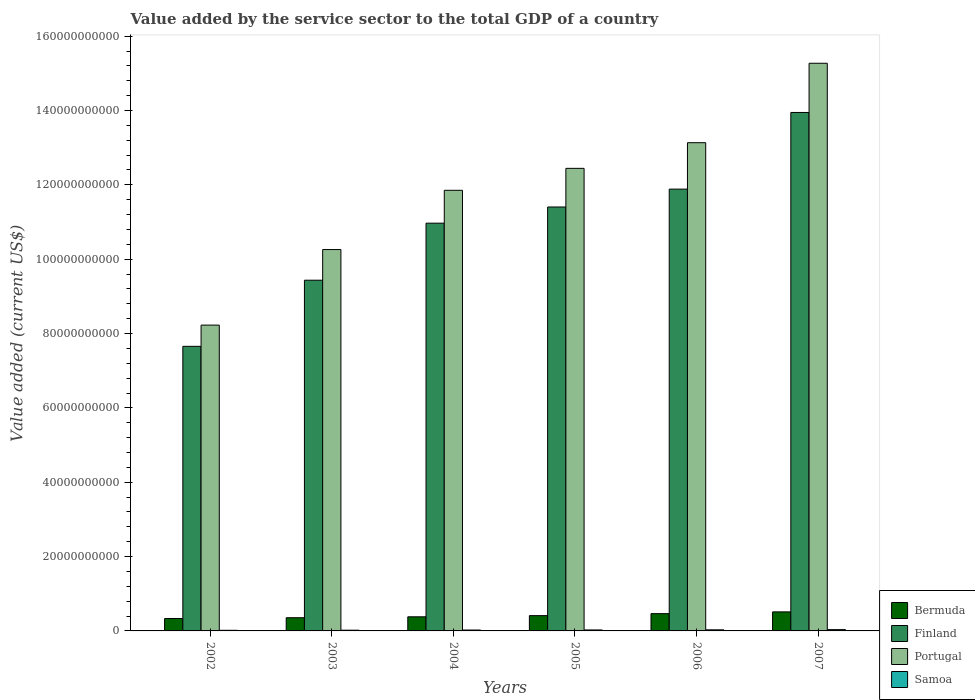How many bars are there on the 5th tick from the right?
Keep it short and to the point. 4. What is the value added by the service sector to the total GDP in Samoa in 2005?
Offer a very short reply. 2.63e+08. Across all years, what is the maximum value added by the service sector to the total GDP in Finland?
Your answer should be very brief. 1.39e+11. Across all years, what is the minimum value added by the service sector to the total GDP in Finland?
Your answer should be very brief. 7.66e+1. In which year was the value added by the service sector to the total GDP in Samoa minimum?
Your response must be concise. 2002. What is the total value added by the service sector to the total GDP in Samoa in the graph?
Keep it short and to the point. 1.51e+09. What is the difference between the value added by the service sector to the total GDP in Samoa in 2006 and that in 2007?
Provide a succinct answer. -5.72e+07. What is the difference between the value added by the service sector to the total GDP in Samoa in 2007 and the value added by the service sector to the total GDP in Finland in 2003?
Ensure brevity in your answer.  -9.40e+1. What is the average value added by the service sector to the total GDP in Bermuda per year?
Your answer should be compact. 4.10e+09. In the year 2004, what is the difference between the value added by the service sector to the total GDP in Samoa and value added by the service sector to the total GDP in Finland?
Offer a very short reply. -1.09e+11. What is the ratio of the value added by the service sector to the total GDP in Bermuda in 2004 to that in 2006?
Make the answer very short. 0.82. Is the difference between the value added by the service sector to the total GDP in Samoa in 2002 and 2006 greater than the difference between the value added by the service sector to the total GDP in Finland in 2002 and 2006?
Ensure brevity in your answer.  Yes. What is the difference between the highest and the second highest value added by the service sector to the total GDP in Bermuda?
Provide a succinct answer. 4.77e+08. What is the difference between the highest and the lowest value added by the service sector to the total GDP in Bermuda?
Your answer should be compact. 1.78e+09. What does the 1st bar from the right in 2003 represents?
Your answer should be compact. Samoa. How many bars are there?
Your response must be concise. 24. How are the legend labels stacked?
Your response must be concise. Vertical. What is the title of the graph?
Provide a short and direct response. Value added by the service sector to the total GDP of a country. Does "Denmark" appear as one of the legend labels in the graph?
Ensure brevity in your answer.  No. What is the label or title of the Y-axis?
Your response must be concise. Value added (current US$). What is the Value added (current US$) of Bermuda in 2002?
Ensure brevity in your answer.  3.34e+09. What is the Value added (current US$) of Finland in 2002?
Make the answer very short. 7.66e+1. What is the Value added (current US$) of Portugal in 2002?
Provide a short and direct response. 8.23e+1. What is the Value added (current US$) of Samoa in 2002?
Your answer should be compact. 1.65e+08. What is the Value added (current US$) of Bermuda in 2003?
Provide a succinct answer. 3.55e+09. What is the Value added (current US$) of Finland in 2003?
Ensure brevity in your answer.  9.43e+1. What is the Value added (current US$) in Portugal in 2003?
Ensure brevity in your answer.  1.03e+11. What is the Value added (current US$) of Samoa in 2003?
Your answer should be very brief. 1.94e+08. What is the Value added (current US$) in Bermuda in 2004?
Offer a very short reply. 3.80e+09. What is the Value added (current US$) of Finland in 2004?
Offer a terse response. 1.10e+11. What is the Value added (current US$) of Portugal in 2004?
Your answer should be very brief. 1.19e+11. What is the Value added (current US$) of Samoa in 2004?
Offer a very short reply. 2.37e+08. What is the Value added (current US$) of Bermuda in 2005?
Your response must be concise. 4.11e+09. What is the Value added (current US$) of Finland in 2005?
Your answer should be compact. 1.14e+11. What is the Value added (current US$) in Portugal in 2005?
Your answer should be compact. 1.24e+11. What is the Value added (current US$) of Samoa in 2005?
Give a very brief answer. 2.63e+08. What is the Value added (current US$) in Bermuda in 2006?
Offer a terse response. 4.65e+09. What is the Value added (current US$) of Finland in 2006?
Offer a very short reply. 1.19e+11. What is the Value added (current US$) of Portugal in 2006?
Give a very brief answer. 1.31e+11. What is the Value added (current US$) in Samoa in 2006?
Your response must be concise. 2.94e+08. What is the Value added (current US$) of Bermuda in 2007?
Your answer should be compact. 5.12e+09. What is the Value added (current US$) of Finland in 2007?
Give a very brief answer. 1.39e+11. What is the Value added (current US$) in Portugal in 2007?
Make the answer very short. 1.53e+11. What is the Value added (current US$) of Samoa in 2007?
Your answer should be very brief. 3.51e+08. Across all years, what is the maximum Value added (current US$) in Bermuda?
Your answer should be very brief. 5.12e+09. Across all years, what is the maximum Value added (current US$) of Finland?
Offer a very short reply. 1.39e+11. Across all years, what is the maximum Value added (current US$) in Portugal?
Give a very brief answer. 1.53e+11. Across all years, what is the maximum Value added (current US$) of Samoa?
Give a very brief answer. 3.51e+08. Across all years, what is the minimum Value added (current US$) of Bermuda?
Give a very brief answer. 3.34e+09. Across all years, what is the minimum Value added (current US$) in Finland?
Provide a short and direct response. 7.66e+1. Across all years, what is the minimum Value added (current US$) in Portugal?
Your answer should be very brief. 8.23e+1. Across all years, what is the minimum Value added (current US$) in Samoa?
Provide a short and direct response. 1.65e+08. What is the total Value added (current US$) in Bermuda in the graph?
Offer a terse response. 2.46e+1. What is the total Value added (current US$) in Finland in the graph?
Keep it short and to the point. 6.53e+11. What is the total Value added (current US$) in Portugal in the graph?
Your answer should be very brief. 7.12e+11. What is the total Value added (current US$) in Samoa in the graph?
Make the answer very short. 1.51e+09. What is the difference between the Value added (current US$) in Bermuda in 2002 and that in 2003?
Give a very brief answer. -2.14e+08. What is the difference between the Value added (current US$) of Finland in 2002 and that in 2003?
Offer a very short reply. -1.78e+1. What is the difference between the Value added (current US$) in Portugal in 2002 and that in 2003?
Provide a short and direct response. -2.03e+1. What is the difference between the Value added (current US$) in Samoa in 2002 and that in 2003?
Provide a succinct answer. -2.92e+07. What is the difference between the Value added (current US$) in Bermuda in 2002 and that in 2004?
Give a very brief answer. -4.59e+08. What is the difference between the Value added (current US$) of Finland in 2002 and that in 2004?
Ensure brevity in your answer.  -3.31e+1. What is the difference between the Value added (current US$) in Portugal in 2002 and that in 2004?
Make the answer very short. -3.63e+1. What is the difference between the Value added (current US$) of Samoa in 2002 and that in 2004?
Offer a very short reply. -7.17e+07. What is the difference between the Value added (current US$) of Bermuda in 2002 and that in 2005?
Keep it short and to the point. -7.73e+08. What is the difference between the Value added (current US$) of Finland in 2002 and that in 2005?
Provide a succinct answer. -3.75e+1. What is the difference between the Value added (current US$) of Portugal in 2002 and that in 2005?
Ensure brevity in your answer.  -4.22e+1. What is the difference between the Value added (current US$) in Samoa in 2002 and that in 2005?
Your answer should be compact. -9.82e+07. What is the difference between the Value added (current US$) in Bermuda in 2002 and that in 2006?
Your answer should be compact. -1.31e+09. What is the difference between the Value added (current US$) in Finland in 2002 and that in 2006?
Give a very brief answer. -4.23e+1. What is the difference between the Value added (current US$) of Portugal in 2002 and that in 2006?
Ensure brevity in your answer.  -4.91e+1. What is the difference between the Value added (current US$) in Samoa in 2002 and that in 2006?
Ensure brevity in your answer.  -1.29e+08. What is the difference between the Value added (current US$) in Bermuda in 2002 and that in 2007?
Your answer should be compact. -1.78e+09. What is the difference between the Value added (current US$) of Finland in 2002 and that in 2007?
Your answer should be very brief. -6.29e+1. What is the difference between the Value added (current US$) in Portugal in 2002 and that in 2007?
Ensure brevity in your answer.  -7.04e+1. What is the difference between the Value added (current US$) of Samoa in 2002 and that in 2007?
Your answer should be very brief. -1.86e+08. What is the difference between the Value added (current US$) of Bermuda in 2003 and that in 2004?
Give a very brief answer. -2.45e+08. What is the difference between the Value added (current US$) in Finland in 2003 and that in 2004?
Ensure brevity in your answer.  -1.53e+1. What is the difference between the Value added (current US$) of Portugal in 2003 and that in 2004?
Offer a very short reply. -1.59e+1. What is the difference between the Value added (current US$) of Samoa in 2003 and that in 2004?
Provide a succinct answer. -4.25e+07. What is the difference between the Value added (current US$) in Bermuda in 2003 and that in 2005?
Offer a terse response. -5.59e+08. What is the difference between the Value added (current US$) of Finland in 2003 and that in 2005?
Offer a very short reply. -1.97e+1. What is the difference between the Value added (current US$) of Portugal in 2003 and that in 2005?
Provide a succinct answer. -2.18e+1. What is the difference between the Value added (current US$) of Samoa in 2003 and that in 2005?
Keep it short and to the point. -6.90e+07. What is the difference between the Value added (current US$) in Bermuda in 2003 and that in 2006?
Offer a very short reply. -1.09e+09. What is the difference between the Value added (current US$) of Finland in 2003 and that in 2006?
Keep it short and to the point. -2.45e+1. What is the difference between the Value added (current US$) in Portugal in 2003 and that in 2006?
Ensure brevity in your answer.  -2.87e+1. What is the difference between the Value added (current US$) in Samoa in 2003 and that in 2006?
Keep it short and to the point. -9.98e+07. What is the difference between the Value added (current US$) of Bermuda in 2003 and that in 2007?
Keep it short and to the point. -1.57e+09. What is the difference between the Value added (current US$) of Finland in 2003 and that in 2007?
Make the answer very short. -4.51e+1. What is the difference between the Value added (current US$) of Portugal in 2003 and that in 2007?
Provide a short and direct response. -5.01e+1. What is the difference between the Value added (current US$) of Samoa in 2003 and that in 2007?
Ensure brevity in your answer.  -1.57e+08. What is the difference between the Value added (current US$) of Bermuda in 2004 and that in 2005?
Your answer should be very brief. -3.14e+08. What is the difference between the Value added (current US$) in Finland in 2004 and that in 2005?
Your response must be concise. -4.35e+09. What is the difference between the Value added (current US$) in Portugal in 2004 and that in 2005?
Offer a terse response. -5.91e+09. What is the difference between the Value added (current US$) of Samoa in 2004 and that in 2005?
Provide a short and direct response. -2.65e+07. What is the difference between the Value added (current US$) in Bermuda in 2004 and that in 2006?
Your response must be concise. -8.46e+08. What is the difference between the Value added (current US$) of Finland in 2004 and that in 2006?
Offer a terse response. -9.16e+09. What is the difference between the Value added (current US$) in Portugal in 2004 and that in 2006?
Provide a short and direct response. -1.28e+1. What is the difference between the Value added (current US$) of Samoa in 2004 and that in 2006?
Provide a short and direct response. -5.73e+07. What is the difference between the Value added (current US$) of Bermuda in 2004 and that in 2007?
Provide a short and direct response. -1.32e+09. What is the difference between the Value added (current US$) in Finland in 2004 and that in 2007?
Provide a short and direct response. -2.98e+1. What is the difference between the Value added (current US$) in Portugal in 2004 and that in 2007?
Offer a very short reply. -3.42e+1. What is the difference between the Value added (current US$) in Samoa in 2004 and that in 2007?
Offer a terse response. -1.15e+08. What is the difference between the Value added (current US$) in Bermuda in 2005 and that in 2006?
Your answer should be compact. -5.32e+08. What is the difference between the Value added (current US$) of Finland in 2005 and that in 2006?
Make the answer very short. -4.81e+09. What is the difference between the Value added (current US$) in Portugal in 2005 and that in 2006?
Offer a very short reply. -6.90e+09. What is the difference between the Value added (current US$) of Samoa in 2005 and that in 2006?
Ensure brevity in your answer.  -3.08e+07. What is the difference between the Value added (current US$) of Bermuda in 2005 and that in 2007?
Your answer should be compact. -1.01e+09. What is the difference between the Value added (current US$) of Finland in 2005 and that in 2007?
Make the answer very short. -2.54e+1. What is the difference between the Value added (current US$) of Portugal in 2005 and that in 2007?
Make the answer very short. -2.83e+1. What is the difference between the Value added (current US$) in Samoa in 2005 and that in 2007?
Provide a short and direct response. -8.81e+07. What is the difference between the Value added (current US$) in Bermuda in 2006 and that in 2007?
Give a very brief answer. -4.77e+08. What is the difference between the Value added (current US$) of Finland in 2006 and that in 2007?
Ensure brevity in your answer.  -2.06e+1. What is the difference between the Value added (current US$) in Portugal in 2006 and that in 2007?
Make the answer very short. -2.14e+1. What is the difference between the Value added (current US$) of Samoa in 2006 and that in 2007?
Give a very brief answer. -5.72e+07. What is the difference between the Value added (current US$) in Bermuda in 2002 and the Value added (current US$) in Finland in 2003?
Make the answer very short. -9.10e+1. What is the difference between the Value added (current US$) of Bermuda in 2002 and the Value added (current US$) of Portugal in 2003?
Offer a very short reply. -9.93e+1. What is the difference between the Value added (current US$) in Bermuda in 2002 and the Value added (current US$) in Samoa in 2003?
Your answer should be very brief. 3.15e+09. What is the difference between the Value added (current US$) of Finland in 2002 and the Value added (current US$) of Portugal in 2003?
Ensure brevity in your answer.  -2.60e+1. What is the difference between the Value added (current US$) of Finland in 2002 and the Value added (current US$) of Samoa in 2003?
Your response must be concise. 7.64e+1. What is the difference between the Value added (current US$) of Portugal in 2002 and the Value added (current US$) of Samoa in 2003?
Offer a terse response. 8.21e+1. What is the difference between the Value added (current US$) in Bermuda in 2002 and the Value added (current US$) in Finland in 2004?
Your response must be concise. -1.06e+11. What is the difference between the Value added (current US$) in Bermuda in 2002 and the Value added (current US$) in Portugal in 2004?
Give a very brief answer. -1.15e+11. What is the difference between the Value added (current US$) of Bermuda in 2002 and the Value added (current US$) of Samoa in 2004?
Offer a terse response. 3.10e+09. What is the difference between the Value added (current US$) in Finland in 2002 and the Value added (current US$) in Portugal in 2004?
Make the answer very short. -4.20e+1. What is the difference between the Value added (current US$) of Finland in 2002 and the Value added (current US$) of Samoa in 2004?
Offer a very short reply. 7.63e+1. What is the difference between the Value added (current US$) in Portugal in 2002 and the Value added (current US$) in Samoa in 2004?
Make the answer very short. 8.20e+1. What is the difference between the Value added (current US$) in Bermuda in 2002 and the Value added (current US$) in Finland in 2005?
Offer a very short reply. -1.11e+11. What is the difference between the Value added (current US$) of Bermuda in 2002 and the Value added (current US$) of Portugal in 2005?
Ensure brevity in your answer.  -1.21e+11. What is the difference between the Value added (current US$) in Bermuda in 2002 and the Value added (current US$) in Samoa in 2005?
Your answer should be very brief. 3.08e+09. What is the difference between the Value added (current US$) in Finland in 2002 and the Value added (current US$) in Portugal in 2005?
Offer a very short reply. -4.79e+1. What is the difference between the Value added (current US$) of Finland in 2002 and the Value added (current US$) of Samoa in 2005?
Offer a terse response. 7.63e+1. What is the difference between the Value added (current US$) of Portugal in 2002 and the Value added (current US$) of Samoa in 2005?
Your answer should be very brief. 8.20e+1. What is the difference between the Value added (current US$) of Bermuda in 2002 and the Value added (current US$) of Finland in 2006?
Your answer should be very brief. -1.16e+11. What is the difference between the Value added (current US$) in Bermuda in 2002 and the Value added (current US$) in Portugal in 2006?
Offer a very short reply. -1.28e+11. What is the difference between the Value added (current US$) in Bermuda in 2002 and the Value added (current US$) in Samoa in 2006?
Keep it short and to the point. 3.05e+09. What is the difference between the Value added (current US$) of Finland in 2002 and the Value added (current US$) of Portugal in 2006?
Make the answer very short. -5.48e+1. What is the difference between the Value added (current US$) of Finland in 2002 and the Value added (current US$) of Samoa in 2006?
Provide a succinct answer. 7.63e+1. What is the difference between the Value added (current US$) of Portugal in 2002 and the Value added (current US$) of Samoa in 2006?
Ensure brevity in your answer.  8.20e+1. What is the difference between the Value added (current US$) of Bermuda in 2002 and the Value added (current US$) of Finland in 2007?
Your answer should be very brief. -1.36e+11. What is the difference between the Value added (current US$) of Bermuda in 2002 and the Value added (current US$) of Portugal in 2007?
Provide a succinct answer. -1.49e+11. What is the difference between the Value added (current US$) of Bermuda in 2002 and the Value added (current US$) of Samoa in 2007?
Keep it short and to the point. 2.99e+09. What is the difference between the Value added (current US$) in Finland in 2002 and the Value added (current US$) in Portugal in 2007?
Keep it short and to the point. -7.61e+1. What is the difference between the Value added (current US$) in Finland in 2002 and the Value added (current US$) in Samoa in 2007?
Offer a very short reply. 7.62e+1. What is the difference between the Value added (current US$) in Portugal in 2002 and the Value added (current US$) in Samoa in 2007?
Provide a succinct answer. 8.19e+1. What is the difference between the Value added (current US$) in Bermuda in 2003 and the Value added (current US$) in Finland in 2004?
Ensure brevity in your answer.  -1.06e+11. What is the difference between the Value added (current US$) of Bermuda in 2003 and the Value added (current US$) of Portugal in 2004?
Your response must be concise. -1.15e+11. What is the difference between the Value added (current US$) in Bermuda in 2003 and the Value added (current US$) in Samoa in 2004?
Provide a succinct answer. 3.32e+09. What is the difference between the Value added (current US$) of Finland in 2003 and the Value added (current US$) of Portugal in 2004?
Your answer should be very brief. -2.42e+1. What is the difference between the Value added (current US$) in Finland in 2003 and the Value added (current US$) in Samoa in 2004?
Provide a succinct answer. 9.41e+1. What is the difference between the Value added (current US$) of Portugal in 2003 and the Value added (current US$) of Samoa in 2004?
Your answer should be compact. 1.02e+11. What is the difference between the Value added (current US$) of Bermuda in 2003 and the Value added (current US$) of Finland in 2005?
Give a very brief answer. -1.10e+11. What is the difference between the Value added (current US$) of Bermuda in 2003 and the Value added (current US$) of Portugal in 2005?
Your response must be concise. -1.21e+11. What is the difference between the Value added (current US$) of Bermuda in 2003 and the Value added (current US$) of Samoa in 2005?
Provide a short and direct response. 3.29e+09. What is the difference between the Value added (current US$) in Finland in 2003 and the Value added (current US$) in Portugal in 2005?
Ensure brevity in your answer.  -3.01e+1. What is the difference between the Value added (current US$) of Finland in 2003 and the Value added (current US$) of Samoa in 2005?
Your response must be concise. 9.41e+1. What is the difference between the Value added (current US$) in Portugal in 2003 and the Value added (current US$) in Samoa in 2005?
Offer a very short reply. 1.02e+11. What is the difference between the Value added (current US$) of Bermuda in 2003 and the Value added (current US$) of Finland in 2006?
Provide a succinct answer. -1.15e+11. What is the difference between the Value added (current US$) in Bermuda in 2003 and the Value added (current US$) in Portugal in 2006?
Provide a short and direct response. -1.28e+11. What is the difference between the Value added (current US$) of Bermuda in 2003 and the Value added (current US$) of Samoa in 2006?
Your response must be concise. 3.26e+09. What is the difference between the Value added (current US$) of Finland in 2003 and the Value added (current US$) of Portugal in 2006?
Offer a very short reply. -3.70e+1. What is the difference between the Value added (current US$) of Finland in 2003 and the Value added (current US$) of Samoa in 2006?
Your answer should be compact. 9.41e+1. What is the difference between the Value added (current US$) of Portugal in 2003 and the Value added (current US$) of Samoa in 2006?
Make the answer very short. 1.02e+11. What is the difference between the Value added (current US$) in Bermuda in 2003 and the Value added (current US$) in Finland in 2007?
Offer a very short reply. -1.36e+11. What is the difference between the Value added (current US$) in Bermuda in 2003 and the Value added (current US$) in Portugal in 2007?
Keep it short and to the point. -1.49e+11. What is the difference between the Value added (current US$) of Bermuda in 2003 and the Value added (current US$) of Samoa in 2007?
Your answer should be very brief. 3.20e+09. What is the difference between the Value added (current US$) in Finland in 2003 and the Value added (current US$) in Portugal in 2007?
Your answer should be very brief. -5.84e+1. What is the difference between the Value added (current US$) of Finland in 2003 and the Value added (current US$) of Samoa in 2007?
Keep it short and to the point. 9.40e+1. What is the difference between the Value added (current US$) in Portugal in 2003 and the Value added (current US$) in Samoa in 2007?
Ensure brevity in your answer.  1.02e+11. What is the difference between the Value added (current US$) of Bermuda in 2004 and the Value added (current US$) of Finland in 2005?
Make the answer very short. -1.10e+11. What is the difference between the Value added (current US$) of Bermuda in 2004 and the Value added (current US$) of Portugal in 2005?
Make the answer very short. -1.21e+11. What is the difference between the Value added (current US$) in Bermuda in 2004 and the Value added (current US$) in Samoa in 2005?
Offer a very short reply. 3.54e+09. What is the difference between the Value added (current US$) in Finland in 2004 and the Value added (current US$) in Portugal in 2005?
Provide a succinct answer. -1.47e+1. What is the difference between the Value added (current US$) of Finland in 2004 and the Value added (current US$) of Samoa in 2005?
Your answer should be compact. 1.09e+11. What is the difference between the Value added (current US$) in Portugal in 2004 and the Value added (current US$) in Samoa in 2005?
Give a very brief answer. 1.18e+11. What is the difference between the Value added (current US$) in Bermuda in 2004 and the Value added (current US$) in Finland in 2006?
Your response must be concise. -1.15e+11. What is the difference between the Value added (current US$) in Bermuda in 2004 and the Value added (current US$) in Portugal in 2006?
Your answer should be compact. -1.28e+11. What is the difference between the Value added (current US$) of Bermuda in 2004 and the Value added (current US$) of Samoa in 2006?
Provide a succinct answer. 3.51e+09. What is the difference between the Value added (current US$) of Finland in 2004 and the Value added (current US$) of Portugal in 2006?
Your response must be concise. -2.16e+1. What is the difference between the Value added (current US$) of Finland in 2004 and the Value added (current US$) of Samoa in 2006?
Keep it short and to the point. 1.09e+11. What is the difference between the Value added (current US$) in Portugal in 2004 and the Value added (current US$) in Samoa in 2006?
Offer a very short reply. 1.18e+11. What is the difference between the Value added (current US$) of Bermuda in 2004 and the Value added (current US$) of Finland in 2007?
Offer a very short reply. -1.36e+11. What is the difference between the Value added (current US$) in Bermuda in 2004 and the Value added (current US$) in Portugal in 2007?
Offer a very short reply. -1.49e+11. What is the difference between the Value added (current US$) of Bermuda in 2004 and the Value added (current US$) of Samoa in 2007?
Your answer should be compact. 3.45e+09. What is the difference between the Value added (current US$) in Finland in 2004 and the Value added (current US$) in Portugal in 2007?
Offer a very short reply. -4.30e+1. What is the difference between the Value added (current US$) of Finland in 2004 and the Value added (current US$) of Samoa in 2007?
Make the answer very short. 1.09e+11. What is the difference between the Value added (current US$) of Portugal in 2004 and the Value added (current US$) of Samoa in 2007?
Provide a succinct answer. 1.18e+11. What is the difference between the Value added (current US$) in Bermuda in 2005 and the Value added (current US$) in Finland in 2006?
Keep it short and to the point. -1.15e+11. What is the difference between the Value added (current US$) in Bermuda in 2005 and the Value added (current US$) in Portugal in 2006?
Your answer should be compact. -1.27e+11. What is the difference between the Value added (current US$) of Bermuda in 2005 and the Value added (current US$) of Samoa in 2006?
Give a very brief answer. 3.82e+09. What is the difference between the Value added (current US$) of Finland in 2005 and the Value added (current US$) of Portugal in 2006?
Offer a terse response. -1.73e+1. What is the difference between the Value added (current US$) in Finland in 2005 and the Value added (current US$) in Samoa in 2006?
Your answer should be compact. 1.14e+11. What is the difference between the Value added (current US$) in Portugal in 2005 and the Value added (current US$) in Samoa in 2006?
Your answer should be compact. 1.24e+11. What is the difference between the Value added (current US$) of Bermuda in 2005 and the Value added (current US$) of Finland in 2007?
Keep it short and to the point. -1.35e+11. What is the difference between the Value added (current US$) in Bermuda in 2005 and the Value added (current US$) in Portugal in 2007?
Your answer should be compact. -1.49e+11. What is the difference between the Value added (current US$) of Bermuda in 2005 and the Value added (current US$) of Samoa in 2007?
Give a very brief answer. 3.76e+09. What is the difference between the Value added (current US$) of Finland in 2005 and the Value added (current US$) of Portugal in 2007?
Your answer should be very brief. -3.87e+1. What is the difference between the Value added (current US$) of Finland in 2005 and the Value added (current US$) of Samoa in 2007?
Give a very brief answer. 1.14e+11. What is the difference between the Value added (current US$) in Portugal in 2005 and the Value added (current US$) in Samoa in 2007?
Keep it short and to the point. 1.24e+11. What is the difference between the Value added (current US$) in Bermuda in 2006 and the Value added (current US$) in Finland in 2007?
Your response must be concise. -1.35e+11. What is the difference between the Value added (current US$) in Bermuda in 2006 and the Value added (current US$) in Portugal in 2007?
Ensure brevity in your answer.  -1.48e+11. What is the difference between the Value added (current US$) in Bermuda in 2006 and the Value added (current US$) in Samoa in 2007?
Offer a terse response. 4.29e+09. What is the difference between the Value added (current US$) in Finland in 2006 and the Value added (current US$) in Portugal in 2007?
Offer a very short reply. -3.39e+1. What is the difference between the Value added (current US$) in Finland in 2006 and the Value added (current US$) in Samoa in 2007?
Provide a short and direct response. 1.18e+11. What is the difference between the Value added (current US$) in Portugal in 2006 and the Value added (current US$) in Samoa in 2007?
Offer a terse response. 1.31e+11. What is the average Value added (current US$) in Bermuda per year?
Your answer should be compact. 4.10e+09. What is the average Value added (current US$) in Finland per year?
Give a very brief answer. 1.09e+11. What is the average Value added (current US$) in Portugal per year?
Your answer should be very brief. 1.19e+11. What is the average Value added (current US$) of Samoa per year?
Provide a succinct answer. 2.51e+08. In the year 2002, what is the difference between the Value added (current US$) of Bermuda and Value added (current US$) of Finland?
Offer a very short reply. -7.32e+1. In the year 2002, what is the difference between the Value added (current US$) of Bermuda and Value added (current US$) of Portugal?
Provide a succinct answer. -7.89e+1. In the year 2002, what is the difference between the Value added (current US$) in Bermuda and Value added (current US$) in Samoa?
Give a very brief answer. 3.18e+09. In the year 2002, what is the difference between the Value added (current US$) of Finland and Value added (current US$) of Portugal?
Offer a terse response. -5.71e+09. In the year 2002, what is the difference between the Value added (current US$) of Finland and Value added (current US$) of Samoa?
Your answer should be very brief. 7.64e+1. In the year 2002, what is the difference between the Value added (current US$) of Portugal and Value added (current US$) of Samoa?
Your answer should be very brief. 8.21e+1. In the year 2003, what is the difference between the Value added (current US$) in Bermuda and Value added (current US$) in Finland?
Ensure brevity in your answer.  -9.08e+1. In the year 2003, what is the difference between the Value added (current US$) in Bermuda and Value added (current US$) in Portugal?
Your response must be concise. -9.90e+1. In the year 2003, what is the difference between the Value added (current US$) of Bermuda and Value added (current US$) of Samoa?
Your answer should be very brief. 3.36e+09. In the year 2003, what is the difference between the Value added (current US$) in Finland and Value added (current US$) in Portugal?
Your answer should be compact. -8.25e+09. In the year 2003, what is the difference between the Value added (current US$) of Finland and Value added (current US$) of Samoa?
Offer a very short reply. 9.41e+1. In the year 2003, what is the difference between the Value added (current US$) in Portugal and Value added (current US$) in Samoa?
Give a very brief answer. 1.02e+11. In the year 2004, what is the difference between the Value added (current US$) of Bermuda and Value added (current US$) of Finland?
Your response must be concise. -1.06e+11. In the year 2004, what is the difference between the Value added (current US$) in Bermuda and Value added (current US$) in Portugal?
Ensure brevity in your answer.  -1.15e+11. In the year 2004, what is the difference between the Value added (current US$) of Bermuda and Value added (current US$) of Samoa?
Your answer should be compact. 3.56e+09. In the year 2004, what is the difference between the Value added (current US$) in Finland and Value added (current US$) in Portugal?
Offer a very short reply. -8.84e+09. In the year 2004, what is the difference between the Value added (current US$) in Finland and Value added (current US$) in Samoa?
Offer a very short reply. 1.09e+11. In the year 2004, what is the difference between the Value added (current US$) in Portugal and Value added (current US$) in Samoa?
Make the answer very short. 1.18e+11. In the year 2005, what is the difference between the Value added (current US$) of Bermuda and Value added (current US$) of Finland?
Offer a very short reply. -1.10e+11. In the year 2005, what is the difference between the Value added (current US$) in Bermuda and Value added (current US$) in Portugal?
Make the answer very short. -1.20e+11. In the year 2005, what is the difference between the Value added (current US$) of Bermuda and Value added (current US$) of Samoa?
Offer a very short reply. 3.85e+09. In the year 2005, what is the difference between the Value added (current US$) in Finland and Value added (current US$) in Portugal?
Provide a succinct answer. -1.04e+1. In the year 2005, what is the difference between the Value added (current US$) of Finland and Value added (current US$) of Samoa?
Offer a very short reply. 1.14e+11. In the year 2005, what is the difference between the Value added (current US$) of Portugal and Value added (current US$) of Samoa?
Your answer should be very brief. 1.24e+11. In the year 2006, what is the difference between the Value added (current US$) in Bermuda and Value added (current US$) in Finland?
Make the answer very short. -1.14e+11. In the year 2006, what is the difference between the Value added (current US$) of Bermuda and Value added (current US$) of Portugal?
Offer a terse response. -1.27e+11. In the year 2006, what is the difference between the Value added (current US$) of Bermuda and Value added (current US$) of Samoa?
Give a very brief answer. 4.35e+09. In the year 2006, what is the difference between the Value added (current US$) in Finland and Value added (current US$) in Portugal?
Your answer should be very brief. -1.25e+1. In the year 2006, what is the difference between the Value added (current US$) of Finland and Value added (current US$) of Samoa?
Provide a succinct answer. 1.19e+11. In the year 2006, what is the difference between the Value added (current US$) of Portugal and Value added (current US$) of Samoa?
Your answer should be compact. 1.31e+11. In the year 2007, what is the difference between the Value added (current US$) of Bermuda and Value added (current US$) of Finland?
Provide a short and direct response. -1.34e+11. In the year 2007, what is the difference between the Value added (current US$) in Bermuda and Value added (current US$) in Portugal?
Your response must be concise. -1.48e+11. In the year 2007, what is the difference between the Value added (current US$) of Bermuda and Value added (current US$) of Samoa?
Offer a terse response. 4.77e+09. In the year 2007, what is the difference between the Value added (current US$) of Finland and Value added (current US$) of Portugal?
Keep it short and to the point. -1.32e+1. In the year 2007, what is the difference between the Value added (current US$) in Finland and Value added (current US$) in Samoa?
Your answer should be compact. 1.39e+11. In the year 2007, what is the difference between the Value added (current US$) in Portugal and Value added (current US$) in Samoa?
Your answer should be compact. 1.52e+11. What is the ratio of the Value added (current US$) of Bermuda in 2002 to that in 2003?
Provide a short and direct response. 0.94. What is the ratio of the Value added (current US$) of Finland in 2002 to that in 2003?
Offer a terse response. 0.81. What is the ratio of the Value added (current US$) of Portugal in 2002 to that in 2003?
Keep it short and to the point. 0.8. What is the ratio of the Value added (current US$) of Samoa in 2002 to that in 2003?
Ensure brevity in your answer.  0.85. What is the ratio of the Value added (current US$) in Bermuda in 2002 to that in 2004?
Give a very brief answer. 0.88. What is the ratio of the Value added (current US$) of Finland in 2002 to that in 2004?
Your answer should be very brief. 0.7. What is the ratio of the Value added (current US$) in Portugal in 2002 to that in 2004?
Keep it short and to the point. 0.69. What is the ratio of the Value added (current US$) in Samoa in 2002 to that in 2004?
Give a very brief answer. 0.7. What is the ratio of the Value added (current US$) of Bermuda in 2002 to that in 2005?
Offer a terse response. 0.81. What is the ratio of the Value added (current US$) in Finland in 2002 to that in 2005?
Provide a succinct answer. 0.67. What is the ratio of the Value added (current US$) of Portugal in 2002 to that in 2005?
Your answer should be very brief. 0.66. What is the ratio of the Value added (current US$) of Samoa in 2002 to that in 2005?
Offer a very short reply. 0.63. What is the ratio of the Value added (current US$) of Bermuda in 2002 to that in 2006?
Make the answer very short. 0.72. What is the ratio of the Value added (current US$) of Finland in 2002 to that in 2006?
Provide a short and direct response. 0.64. What is the ratio of the Value added (current US$) in Portugal in 2002 to that in 2006?
Offer a terse response. 0.63. What is the ratio of the Value added (current US$) in Samoa in 2002 to that in 2006?
Offer a terse response. 0.56. What is the ratio of the Value added (current US$) of Bermuda in 2002 to that in 2007?
Your response must be concise. 0.65. What is the ratio of the Value added (current US$) in Finland in 2002 to that in 2007?
Provide a succinct answer. 0.55. What is the ratio of the Value added (current US$) in Portugal in 2002 to that in 2007?
Your answer should be compact. 0.54. What is the ratio of the Value added (current US$) in Samoa in 2002 to that in 2007?
Give a very brief answer. 0.47. What is the ratio of the Value added (current US$) in Bermuda in 2003 to that in 2004?
Ensure brevity in your answer.  0.94. What is the ratio of the Value added (current US$) of Finland in 2003 to that in 2004?
Your response must be concise. 0.86. What is the ratio of the Value added (current US$) of Portugal in 2003 to that in 2004?
Make the answer very short. 0.87. What is the ratio of the Value added (current US$) of Samoa in 2003 to that in 2004?
Provide a short and direct response. 0.82. What is the ratio of the Value added (current US$) of Bermuda in 2003 to that in 2005?
Keep it short and to the point. 0.86. What is the ratio of the Value added (current US$) in Finland in 2003 to that in 2005?
Give a very brief answer. 0.83. What is the ratio of the Value added (current US$) in Portugal in 2003 to that in 2005?
Offer a very short reply. 0.82. What is the ratio of the Value added (current US$) in Samoa in 2003 to that in 2005?
Keep it short and to the point. 0.74. What is the ratio of the Value added (current US$) in Bermuda in 2003 to that in 2006?
Ensure brevity in your answer.  0.77. What is the ratio of the Value added (current US$) in Finland in 2003 to that in 2006?
Offer a terse response. 0.79. What is the ratio of the Value added (current US$) of Portugal in 2003 to that in 2006?
Your response must be concise. 0.78. What is the ratio of the Value added (current US$) of Samoa in 2003 to that in 2006?
Your response must be concise. 0.66. What is the ratio of the Value added (current US$) of Bermuda in 2003 to that in 2007?
Your answer should be very brief. 0.69. What is the ratio of the Value added (current US$) of Finland in 2003 to that in 2007?
Offer a terse response. 0.68. What is the ratio of the Value added (current US$) in Portugal in 2003 to that in 2007?
Your response must be concise. 0.67. What is the ratio of the Value added (current US$) in Samoa in 2003 to that in 2007?
Ensure brevity in your answer.  0.55. What is the ratio of the Value added (current US$) of Bermuda in 2004 to that in 2005?
Keep it short and to the point. 0.92. What is the ratio of the Value added (current US$) in Finland in 2004 to that in 2005?
Your response must be concise. 0.96. What is the ratio of the Value added (current US$) of Portugal in 2004 to that in 2005?
Give a very brief answer. 0.95. What is the ratio of the Value added (current US$) in Samoa in 2004 to that in 2005?
Your answer should be compact. 0.9. What is the ratio of the Value added (current US$) in Bermuda in 2004 to that in 2006?
Your response must be concise. 0.82. What is the ratio of the Value added (current US$) in Finland in 2004 to that in 2006?
Ensure brevity in your answer.  0.92. What is the ratio of the Value added (current US$) of Portugal in 2004 to that in 2006?
Make the answer very short. 0.9. What is the ratio of the Value added (current US$) in Samoa in 2004 to that in 2006?
Make the answer very short. 0.81. What is the ratio of the Value added (current US$) in Bermuda in 2004 to that in 2007?
Give a very brief answer. 0.74. What is the ratio of the Value added (current US$) of Finland in 2004 to that in 2007?
Ensure brevity in your answer.  0.79. What is the ratio of the Value added (current US$) of Portugal in 2004 to that in 2007?
Offer a terse response. 0.78. What is the ratio of the Value added (current US$) of Samoa in 2004 to that in 2007?
Make the answer very short. 0.67. What is the ratio of the Value added (current US$) of Bermuda in 2005 to that in 2006?
Offer a very short reply. 0.89. What is the ratio of the Value added (current US$) of Finland in 2005 to that in 2006?
Your answer should be compact. 0.96. What is the ratio of the Value added (current US$) in Portugal in 2005 to that in 2006?
Give a very brief answer. 0.95. What is the ratio of the Value added (current US$) in Samoa in 2005 to that in 2006?
Keep it short and to the point. 0.9. What is the ratio of the Value added (current US$) in Bermuda in 2005 to that in 2007?
Keep it short and to the point. 0.8. What is the ratio of the Value added (current US$) of Finland in 2005 to that in 2007?
Offer a terse response. 0.82. What is the ratio of the Value added (current US$) in Portugal in 2005 to that in 2007?
Offer a terse response. 0.81. What is the ratio of the Value added (current US$) in Samoa in 2005 to that in 2007?
Your response must be concise. 0.75. What is the ratio of the Value added (current US$) in Bermuda in 2006 to that in 2007?
Ensure brevity in your answer.  0.91. What is the ratio of the Value added (current US$) of Finland in 2006 to that in 2007?
Offer a terse response. 0.85. What is the ratio of the Value added (current US$) in Portugal in 2006 to that in 2007?
Your answer should be very brief. 0.86. What is the ratio of the Value added (current US$) in Samoa in 2006 to that in 2007?
Give a very brief answer. 0.84. What is the difference between the highest and the second highest Value added (current US$) of Bermuda?
Offer a very short reply. 4.77e+08. What is the difference between the highest and the second highest Value added (current US$) of Finland?
Your answer should be compact. 2.06e+1. What is the difference between the highest and the second highest Value added (current US$) of Portugal?
Provide a short and direct response. 2.14e+1. What is the difference between the highest and the second highest Value added (current US$) in Samoa?
Offer a terse response. 5.72e+07. What is the difference between the highest and the lowest Value added (current US$) of Bermuda?
Ensure brevity in your answer.  1.78e+09. What is the difference between the highest and the lowest Value added (current US$) of Finland?
Give a very brief answer. 6.29e+1. What is the difference between the highest and the lowest Value added (current US$) in Portugal?
Your answer should be compact. 7.04e+1. What is the difference between the highest and the lowest Value added (current US$) in Samoa?
Offer a terse response. 1.86e+08. 